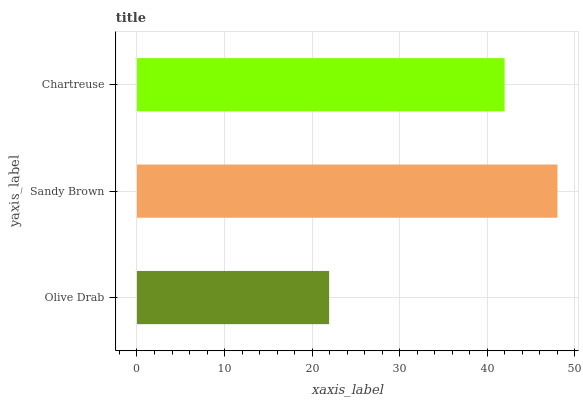Is Olive Drab the minimum?
Answer yes or no. Yes. Is Sandy Brown the maximum?
Answer yes or no. Yes. Is Chartreuse the minimum?
Answer yes or no. No. Is Chartreuse the maximum?
Answer yes or no. No. Is Sandy Brown greater than Chartreuse?
Answer yes or no. Yes. Is Chartreuse less than Sandy Brown?
Answer yes or no. Yes. Is Chartreuse greater than Sandy Brown?
Answer yes or no. No. Is Sandy Brown less than Chartreuse?
Answer yes or no. No. Is Chartreuse the high median?
Answer yes or no. Yes. Is Chartreuse the low median?
Answer yes or no. Yes. Is Olive Drab the high median?
Answer yes or no. No. Is Olive Drab the low median?
Answer yes or no. No. 